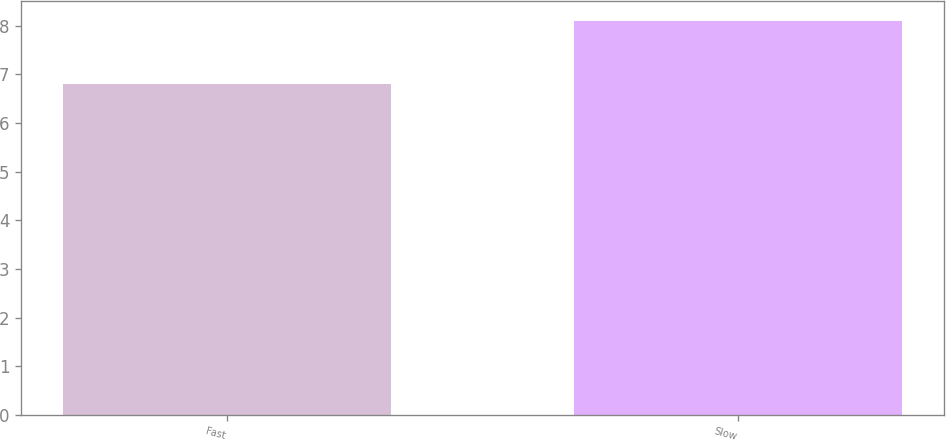Convert chart to OTSL. <chart><loc_0><loc_0><loc_500><loc_500><bar_chart><fcel>Fast<fcel>Slow<nl><fcel>6.8<fcel>8.1<nl></chart> 